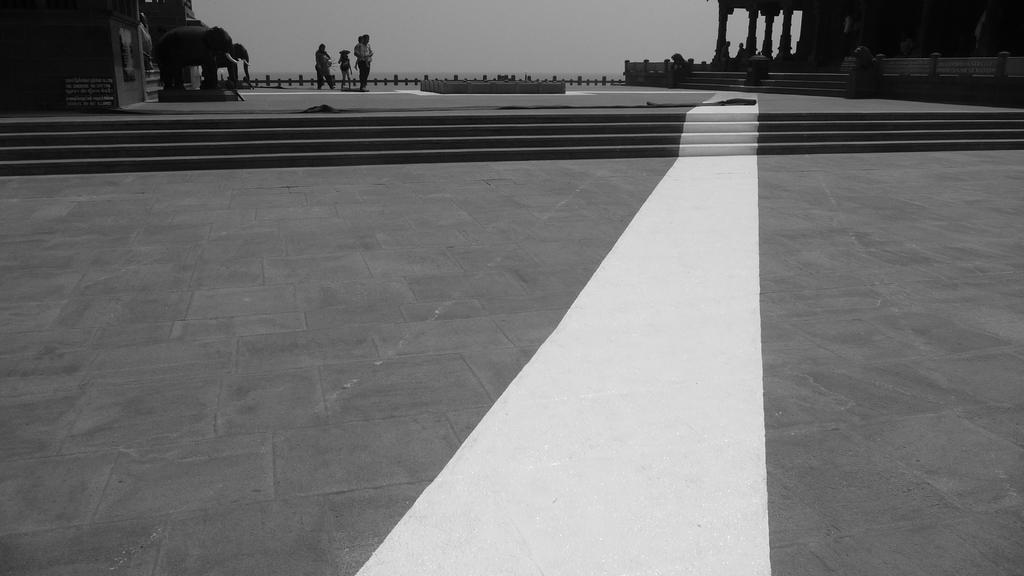Could you give a brief overview of what you see in this image? This is a black and white image. These are the stairs. I can see the sculptures of two elephants standing. There is a group of people standing. I think this is the temple with sculptures and pillars. This looks like a board. 